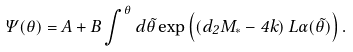<formula> <loc_0><loc_0><loc_500><loc_500>\Psi ( \theta ) = A + B \int ^ { \theta } d \tilde { \theta } \exp \left ( \left ( d _ { 2 } M _ { * } - 4 k \right ) L \alpha ( \tilde { \theta } ) \right ) .</formula> 